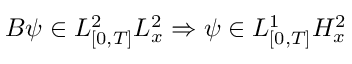<formula> <loc_0><loc_0><loc_500><loc_500>B \psi \in L _ { [ 0 , T ] } ^ { 2 } L _ { x } ^ { 2 } \Rightarrow \psi \in L _ { [ 0 , T ] } ^ { 1 } H _ { x } ^ { 2 }</formula> 